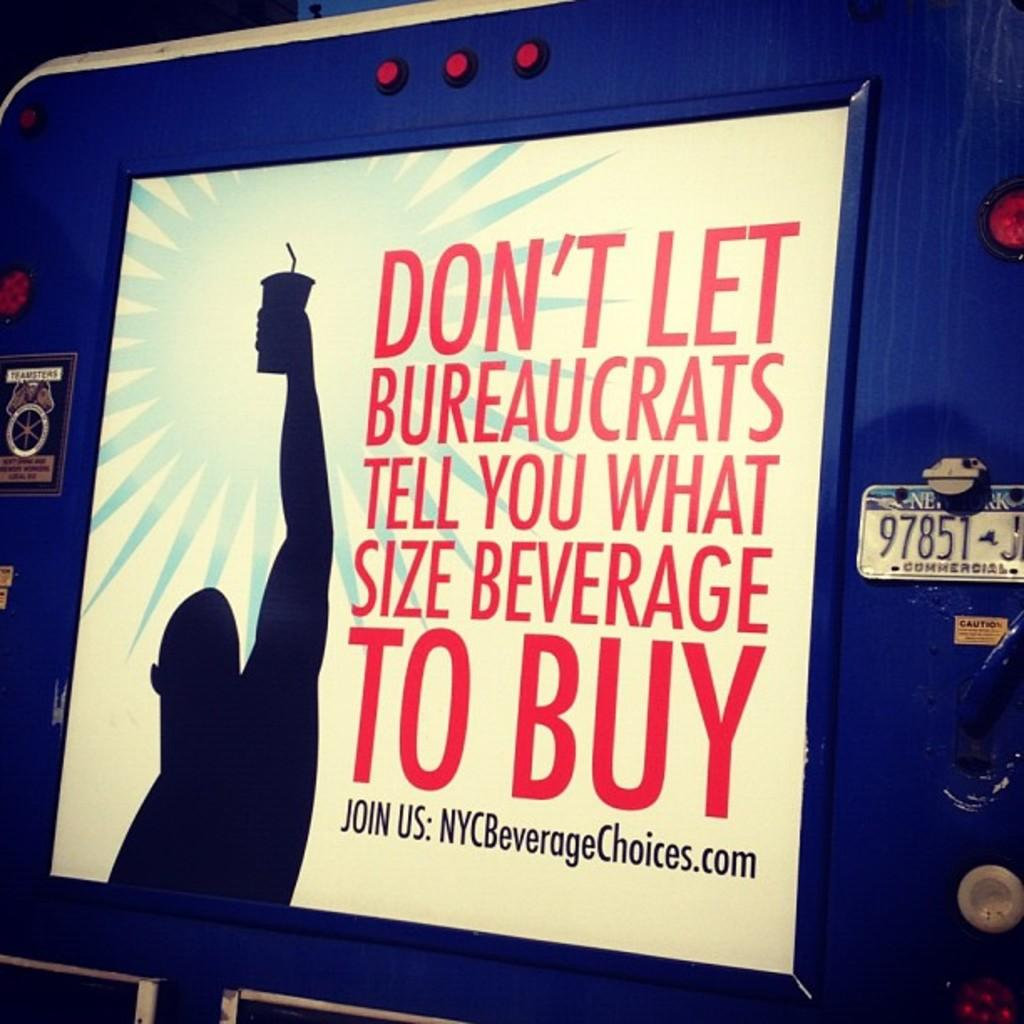<image>
Write a terse but informative summary of the picture. an ad that is about freedom to choose beverages 